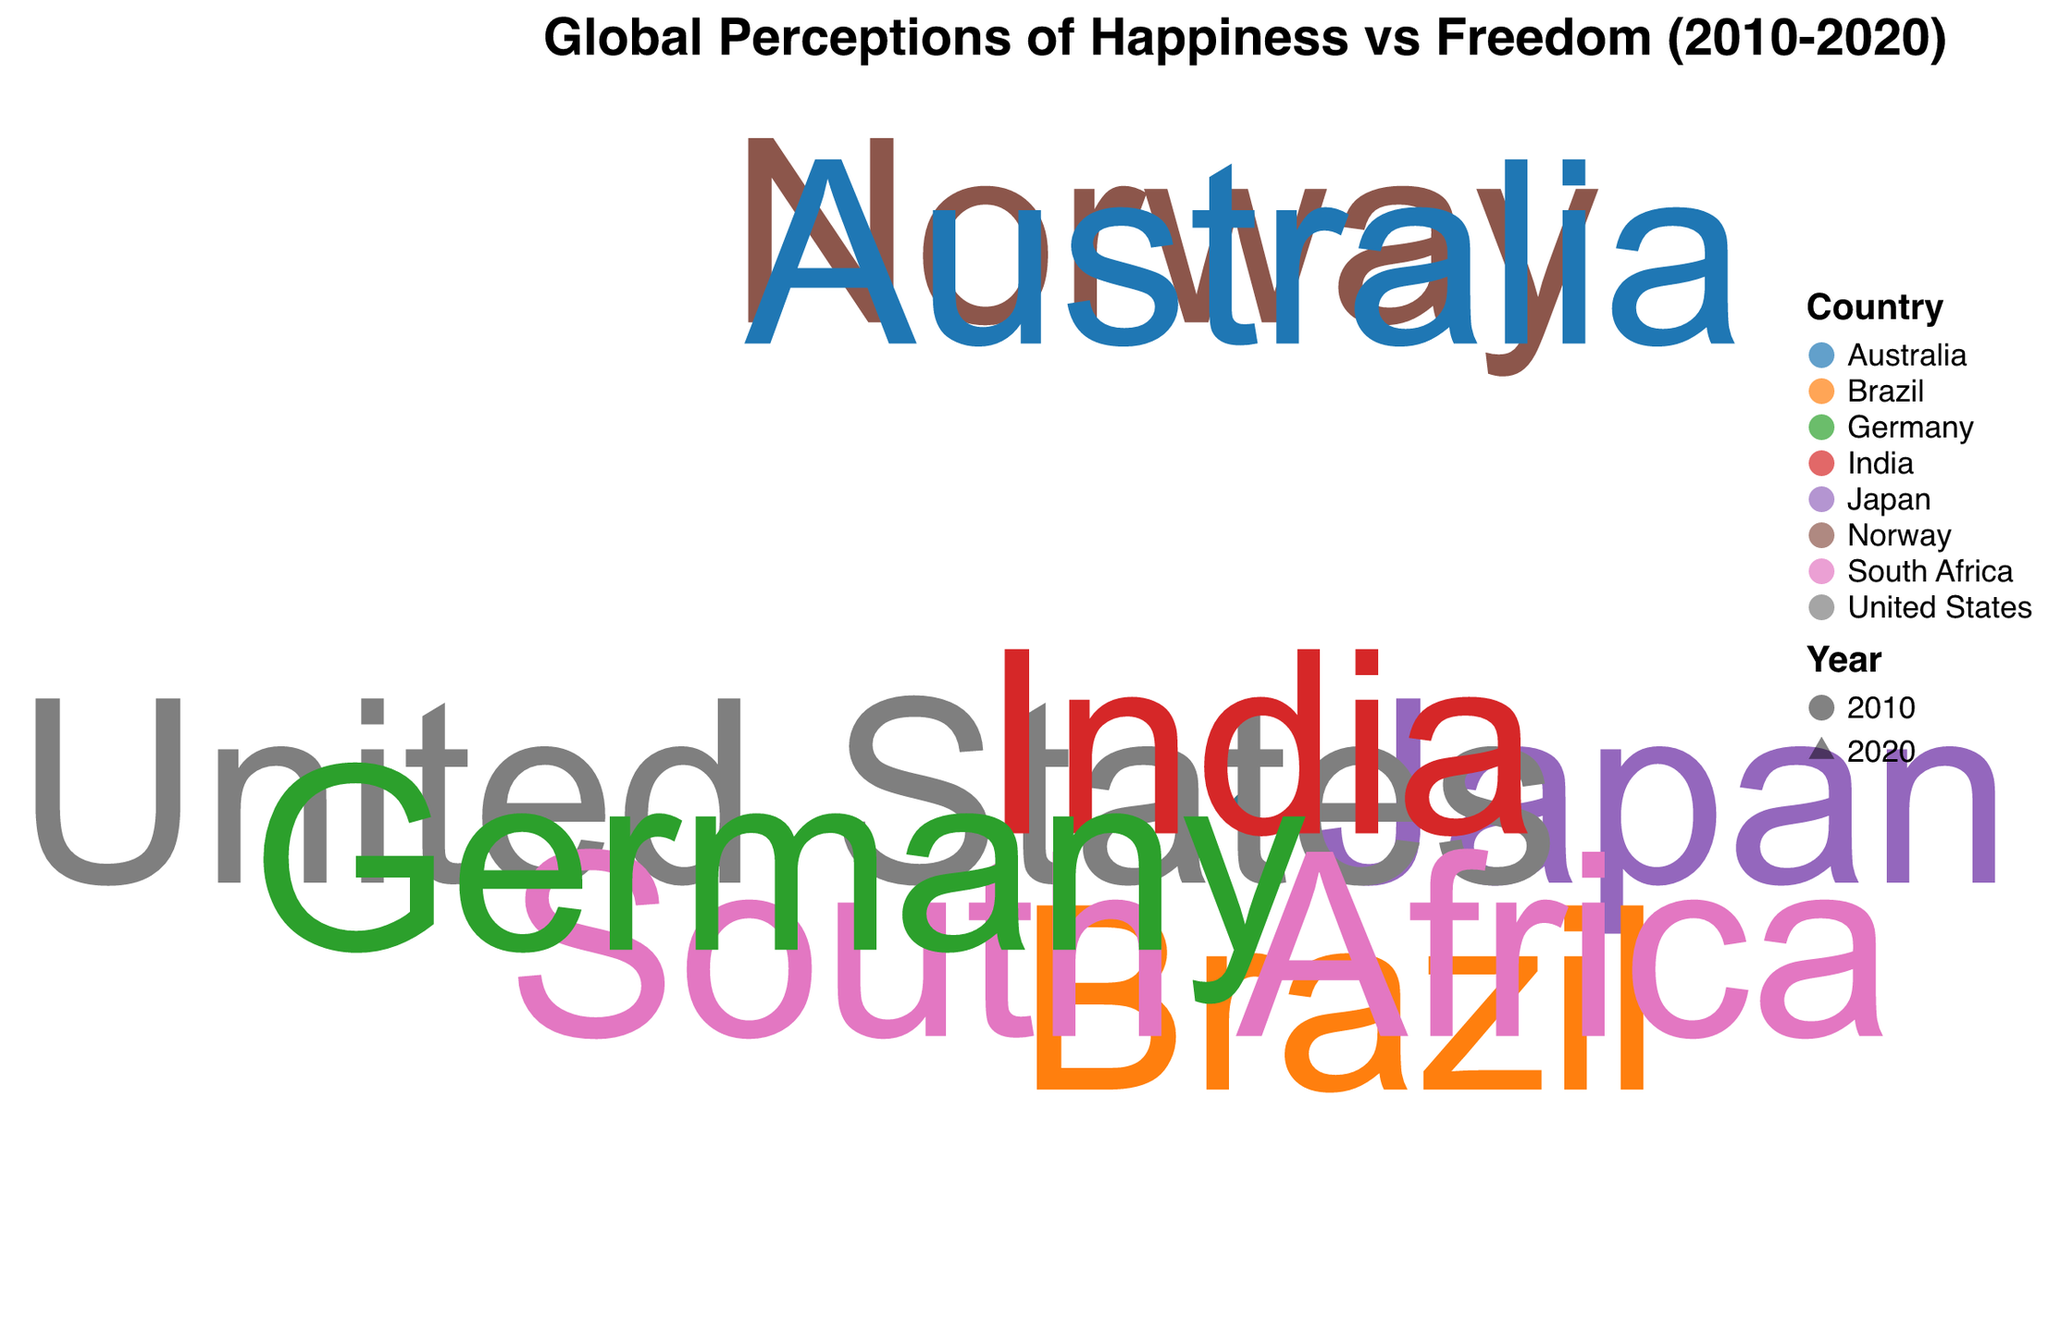What is the title of the figure? The title is displayed at the top of the figure, indicating the main purpose of the visualization, which is the global perceptions of happiness and freedom from 2010 to 2020.
Answer: Global Perceptions of Happiness vs Freedom (2010-2020) Which country has the highest happiness score in 2020? The figure uses both color and text labels to indicate countries and their respective data points. By examining the radius (happiness score) for each year labeled 2020, we can determine which has the highest value. In this case, Australia shows the highest score.
Answer: Australia What shape represents the data points for the year 2020? The encoding of shapes indicates that data points for the year 2020 are represented by triangles, as opposed to circles for the year 2010. This can be identified through the visual shapes in the figure.
Answer: Triangles Which country had a drop in both happiness and freedom scores from 2010 to 2020? By comparing the data points for each country between 2010 and 2020, it is clear that Brazil saw a drop in both its happiness and freedom scores.
Answer: Brazil How does Japan’s freedom score change from 2010 to 2020? Observing the theta (angle) for Japan in both years and noting the difference, it is visible that Japan's freedom score increases slightly from 4.8 in 2010 to 5.0 in 2020.
Answer: Increase Which country showed the largest increase in happiness score from 2010 to 2020? To find the country with the largest increase, we compare the difference in radius for each country between 2010 and 2020. Norway has an increase of 0.3 in its happiness score, from 7.3 to 7.6.
Answer: Norway How are the happiness and freedom scores of Germany in 2010 and 2020 visually presented? The happiness and freedom scores are plotted with the radius representing happiness and theta representing freedom. For Germany, both years appear slightly above the central area, showing stability in its scores: 6.7 to 6.9 for happiness and 7.0 to 7.1 for freedom.
Answer: Stable and slightly improved scores What trend can be seen regarding South Africa’s freedom score from 2010 to 2020? Looking at the theta value for both years for South Africa, we see a slight increase from 6.0 in 2010 to 6.3 in 2020, indicating a positive trend.
Answer: Increase What can be inferred about India's overall emotional and freedom perception between 2010 and 2020? Observing India’s radius and theta, both show slight increases from 2010 to 2020, indicating a small improvement in both happiness (4.0 to 3.8) and freedom scores (3.9 to 4.1).
Answer: Slight improvement in both scores 